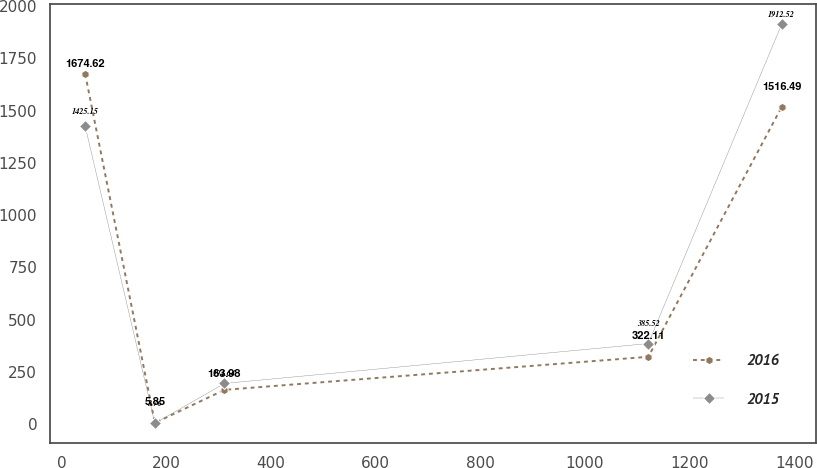Convert chart to OTSL. <chart><loc_0><loc_0><loc_500><loc_500><line_chart><ecel><fcel>2016<fcel>2015<nl><fcel>44.62<fcel>1674.62<fcel>1425.15<nl><fcel>177.72<fcel>5.85<fcel>3.76<nl><fcel>310.82<fcel>163.98<fcel>194.64<nl><fcel>1120.91<fcel>322.11<fcel>385.52<nl><fcel>1375.66<fcel>1516.49<fcel>1912.52<nl></chart> 